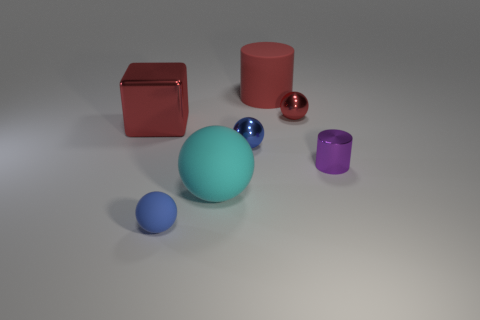Subtract all small balls. How many balls are left? 1 Subtract all blue spheres. How many spheres are left? 2 Subtract all spheres. How many objects are left? 3 Subtract 1 cylinders. How many cylinders are left? 1 Subtract all cyan cylinders. Subtract all yellow spheres. How many cylinders are left? 2 Subtract all purple cubes. How many blue spheres are left? 2 Subtract all cylinders. Subtract all brown metal spheres. How many objects are left? 5 Add 7 red rubber cylinders. How many red rubber cylinders are left? 8 Add 4 tiny brown metallic objects. How many tiny brown metallic objects exist? 4 Add 1 red metallic cubes. How many objects exist? 8 